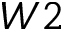<formula> <loc_0><loc_0><loc_500><loc_500>W 2</formula> 